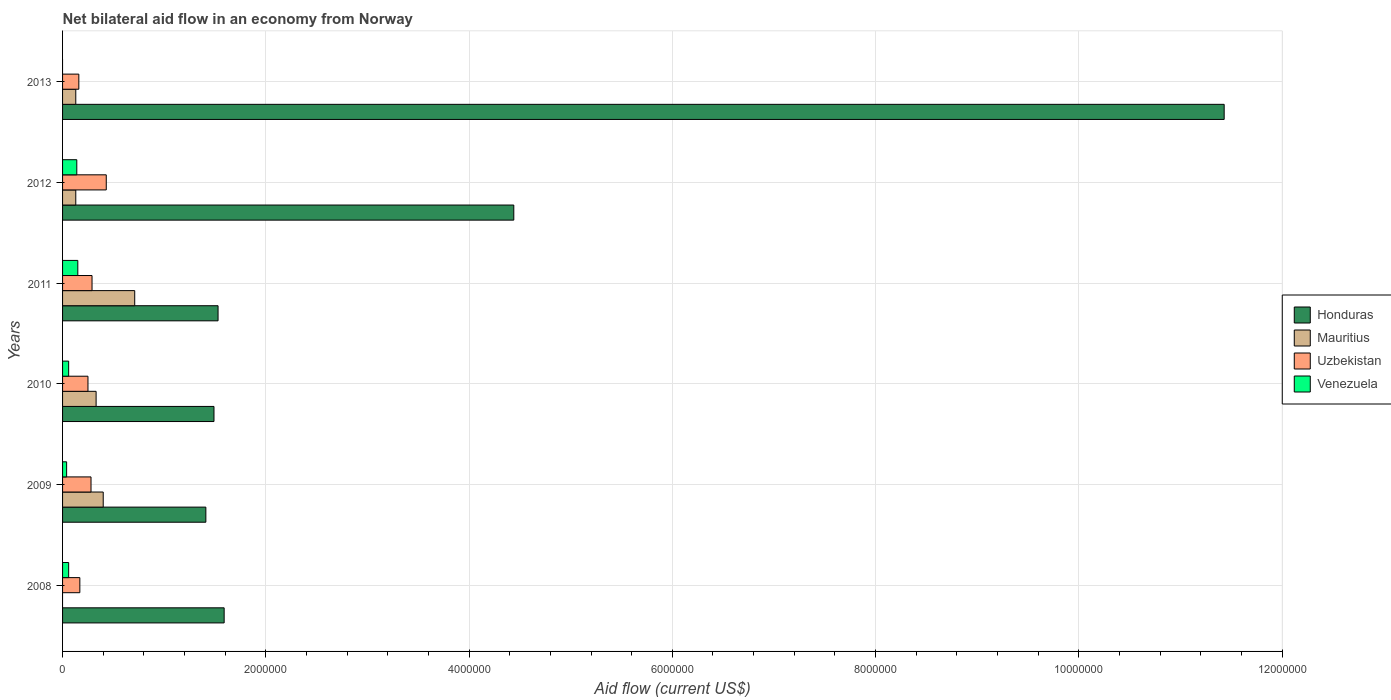Are the number of bars per tick equal to the number of legend labels?
Provide a short and direct response. No. In how many cases, is the number of bars for a given year not equal to the number of legend labels?
Provide a succinct answer. 2. What is the net bilateral aid flow in Venezuela in 2010?
Provide a short and direct response. 6.00e+04. Across all years, what is the maximum net bilateral aid flow in Mauritius?
Keep it short and to the point. 7.10e+05. In which year was the net bilateral aid flow in Venezuela maximum?
Your answer should be compact. 2011. What is the total net bilateral aid flow in Honduras in the graph?
Ensure brevity in your answer.  2.19e+07. What is the difference between the net bilateral aid flow in Honduras in 2008 and the net bilateral aid flow in Uzbekistan in 2013?
Provide a short and direct response. 1.43e+06. What is the average net bilateral aid flow in Honduras per year?
Offer a very short reply. 3.65e+06. In the year 2010, what is the difference between the net bilateral aid flow in Mauritius and net bilateral aid flow in Honduras?
Your answer should be compact. -1.16e+06. In how many years, is the net bilateral aid flow in Honduras greater than 8000000 US$?
Your answer should be compact. 1. What is the ratio of the net bilateral aid flow in Honduras in 2008 to that in 2011?
Ensure brevity in your answer.  1.04. Is the difference between the net bilateral aid flow in Mauritius in 2012 and 2013 greater than the difference between the net bilateral aid flow in Honduras in 2012 and 2013?
Offer a terse response. Yes. What is the difference between the highest and the second highest net bilateral aid flow in Venezuela?
Your answer should be compact. 10000. What is the difference between the highest and the lowest net bilateral aid flow in Mauritius?
Keep it short and to the point. 7.10e+05. Is the sum of the net bilateral aid flow in Venezuela in 2009 and 2010 greater than the maximum net bilateral aid flow in Mauritius across all years?
Keep it short and to the point. No. Is it the case that in every year, the sum of the net bilateral aid flow in Honduras and net bilateral aid flow in Uzbekistan is greater than the sum of net bilateral aid flow in Mauritius and net bilateral aid flow in Venezuela?
Provide a short and direct response. No. Are all the bars in the graph horizontal?
Provide a short and direct response. Yes. What is the difference between two consecutive major ticks on the X-axis?
Make the answer very short. 2.00e+06. Does the graph contain grids?
Make the answer very short. Yes. How many legend labels are there?
Offer a very short reply. 4. What is the title of the graph?
Keep it short and to the point. Net bilateral aid flow in an economy from Norway. What is the Aid flow (current US$) of Honduras in 2008?
Your answer should be compact. 1.59e+06. What is the Aid flow (current US$) of Honduras in 2009?
Your answer should be very brief. 1.41e+06. What is the Aid flow (current US$) of Mauritius in 2009?
Ensure brevity in your answer.  4.00e+05. What is the Aid flow (current US$) in Uzbekistan in 2009?
Provide a succinct answer. 2.80e+05. What is the Aid flow (current US$) in Honduras in 2010?
Ensure brevity in your answer.  1.49e+06. What is the Aid flow (current US$) in Honduras in 2011?
Offer a terse response. 1.53e+06. What is the Aid flow (current US$) of Mauritius in 2011?
Provide a succinct answer. 7.10e+05. What is the Aid flow (current US$) of Uzbekistan in 2011?
Your response must be concise. 2.90e+05. What is the Aid flow (current US$) in Venezuela in 2011?
Provide a succinct answer. 1.50e+05. What is the Aid flow (current US$) of Honduras in 2012?
Your answer should be compact. 4.44e+06. What is the Aid flow (current US$) of Venezuela in 2012?
Offer a terse response. 1.40e+05. What is the Aid flow (current US$) in Honduras in 2013?
Provide a succinct answer. 1.14e+07. What is the Aid flow (current US$) in Mauritius in 2013?
Give a very brief answer. 1.30e+05. What is the Aid flow (current US$) in Uzbekistan in 2013?
Keep it short and to the point. 1.60e+05. What is the Aid flow (current US$) of Venezuela in 2013?
Provide a succinct answer. 0. Across all years, what is the maximum Aid flow (current US$) in Honduras?
Provide a short and direct response. 1.14e+07. Across all years, what is the maximum Aid flow (current US$) of Mauritius?
Give a very brief answer. 7.10e+05. Across all years, what is the minimum Aid flow (current US$) in Honduras?
Your answer should be very brief. 1.41e+06. Across all years, what is the minimum Aid flow (current US$) in Mauritius?
Ensure brevity in your answer.  0. Across all years, what is the minimum Aid flow (current US$) in Uzbekistan?
Ensure brevity in your answer.  1.60e+05. Across all years, what is the minimum Aid flow (current US$) of Venezuela?
Make the answer very short. 0. What is the total Aid flow (current US$) in Honduras in the graph?
Keep it short and to the point. 2.19e+07. What is the total Aid flow (current US$) in Mauritius in the graph?
Offer a terse response. 1.70e+06. What is the total Aid flow (current US$) in Uzbekistan in the graph?
Your response must be concise. 1.58e+06. What is the difference between the Aid flow (current US$) of Honduras in 2008 and that in 2009?
Give a very brief answer. 1.80e+05. What is the difference between the Aid flow (current US$) of Uzbekistan in 2008 and that in 2009?
Your answer should be compact. -1.10e+05. What is the difference between the Aid flow (current US$) of Honduras in 2008 and that in 2011?
Ensure brevity in your answer.  6.00e+04. What is the difference between the Aid flow (current US$) in Uzbekistan in 2008 and that in 2011?
Offer a very short reply. -1.20e+05. What is the difference between the Aid flow (current US$) of Venezuela in 2008 and that in 2011?
Ensure brevity in your answer.  -9.00e+04. What is the difference between the Aid flow (current US$) in Honduras in 2008 and that in 2012?
Make the answer very short. -2.85e+06. What is the difference between the Aid flow (current US$) of Venezuela in 2008 and that in 2012?
Give a very brief answer. -8.00e+04. What is the difference between the Aid flow (current US$) of Honduras in 2008 and that in 2013?
Your answer should be very brief. -9.84e+06. What is the difference between the Aid flow (current US$) in Uzbekistan in 2008 and that in 2013?
Provide a succinct answer. 10000. What is the difference between the Aid flow (current US$) in Honduras in 2009 and that in 2010?
Your answer should be very brief. -8.00e+04. What is the difference between the Aid flow (current US$) in Mauritius in 2009 and that in 2010?
Your response must be concise. 7.00e+04. What is the difference between the Aid flow (current US$) in Uzbekistan in 2009 and that in 2010?
Provide a short and direct response. 3.00e+04. What is the difference between the Aid flow (current US$) of Venezuela in 2009 and that in 2010?
Give a very brief answer. -2.00e+04. What is the difference between the Aid flow (current US$) of Mauritius in 2009 and that in 2011?
Offer a terse response. -3.10e+05. What is the difference between the Aid flow (current US$) in Honduras in 2009 and that in 2012?
Offer a terse response. -3.03e+06. What is the difference between the Aid flow (current US$) of Venezuela in 2009 and that in 2012?
Provide a succinct answer. -1.00e+05. What is the difference between the Aid flow (current US$) in Honduras in 2009 and that in 2013?
Your answer should be very brief. -1.00e+07. What is the difference between the Aid flow (current US$) of Mauritius in 2009 and that in 2013?
Provide a short and direct response. 2.70e+05. What is the difference between the Aid flow (current US$) in Uzbekistan in 2009 and that in 2013?
Offer a terse response. 1.20e+05. What is the difference between the Aid flow (current US$) of Mauritius in 2010 and that in 2011?
Give a very brief answer. -3.80e+05. What is the difference between the Aid flow (current US$) of Uzbekistan in 2010 and that in 2011?
Your answer should be compact. -4.00e+04. What is the difference between the Aid flow (current US$) of Venezuela in 2010 and that in 2011?
Offer a very short reply. -9.00e+04. What is the difference between the Aid flow (current US$) of Honduras in 2010 and that in 2012?
Offer a terse response. -2.95e+06. What is the difference between the Aid flow (current US$) of Mauritius in 2010 and that in 2012?
Ensure brevity in your answer.  2.00e+05. What is the difference between the Aid flow (current US$) in Uzbekistan in 2010 and that in 2012?
Offer a terse response. -1.80e+05. What is the difference between the Aid flow (current US$) in Venezuela in 2010 and that in 2012?
Your answer should be compact. -8.00e+04. What is the difference between the Aid flow (current US$) in Honduras in 2010 and that in 2013?
Give a very brief answer. -9.94e+06. What is the difference between the Aid flow (current US$) in Mauritius in 2010 and that in 2013?
Offer a very short reply. 2.00e+05. What is the difference between the Aid flow (current US$) in Uzbekistan in 2010 and that in 2013?
Give a very brief answer. 9.00e+04. What is the difference between the Aid flow (current US$) of Honduras in 2011 and that in 2012?
Offer a very short reply. -2.91e+06. What is the difference between the Aid flow (current US$) of Mauritius in 2011 and that in 2012?
Keep it short and to the point. 5.80e+05. What is the difference between the Aid flow (current US$) of Uzbekistan in 2011 and that in 2012?
Your response must be concise. -1.40e+05. What is the difference between the Aid flow (current US$) in Venezuela in 2011 and that in 2012?
Provide a succinct answer. 10000. What is the difference between the Aid flow (current US$) of Honduras in 2011 and that in 2013?
Offer a very short reply. -9.90e+06. What is the difference between the Aid flow (current US$) in Mauritius in 2011 and that in 2013?
Offer a terse response. 5.80e+05. What is the difference between the Aid flow (current US$) of Uzbekistan in 2011 and that in 2013?
Your response must be concise. 1.30e+05. What is the difference between the Aid flow (current US$) in Honduras in 2012 and that in 2013?
Your response must be concise. -6.99e+06. What is the difference between the Aid flow (current US$) in Mauritius in 2012 and that in 2013?
Your answer should be very brief. 0. What is the difference between the Aid flow (current US$) of Uzbekistan in 2012 and that in 2013?
Your response must be concise. 2.70e+05. What is the difference between the Aid flow (current US$) in Honduras in 2008 and the Aid flow (current US$) in Mauritius in 2009?
Offer a very short reply. 1.19e+06. What is the difference between the Aid flow (current US$) of Honduras in 2008 and the Aid flow (current US$) of Uzbekistan in 2009?
Ensure brevity in your answer.  1.31e+06. What is the difference between the Aid flow (current US$) in Honduras in 2008 and the Aid flow (current US$) in Venezuela in 2009?
Your answer should be compact. 1.55e+06. What is the difference between the Aid flow (current US$) in Uzbekistan in 2008 and the Aid flow (current US$) in Venezuela in 2009?
Keep it short and to the point. 1.30e+05. What is the difference between the Aid flow (current US$) of Honduras in 2008 and the Aid flow (current US$) of Mauritius in 2010?
Give a very brief answer. 1.26e+06. What is the difference between the Aid flow (current US$) in Honduras in 2008 and the Aid flow (current US$) in Uzbekistan in 2010?
Your answer should be very brief. 1.34e+06. What is the difference between the Aid flow (current US$) in Honduras in 2008 and the Aid flow (current US$) in Venezuela in 2010?
Your answer should be compact. 1.53e+06. What is the difference between the Aid flow (current US$) in Uzbekistan in 2008 and the Aid flow (current US$) in Venezuela in 2010?
Provide a succinct answer. 1.10e+05. What is the difference between the Aid flow (current US$) of Honduras in 2008 and the Aid flow (current US$) of Mauritius in 2011?
Offer a very short reply. 8.80e+05. What is the difference between the Aid flow (current US$) in Honduras in 2008 and the Aid flow (current US$) in Uzbekistan in 2011?
Your response must be concise. 1.30e+06. What is the difference between the Aid flow (current US$) of Honduras in 2008 and the Aid flow (current US$) of Venezuela in 2011?
Keep it short and to the point. 1.44e+06. What is the difference between the Aid flow (current US$) in Honduras in 2008 and the Aid flow (current US$) in Mauritius in 2012?
Provide a succinct answer. 1.46e+06. What is the difference between the Aid flow (current US$) in Honduras in 2008 and the Aid flow (current US$) in Uzbekistan in 2012?
Offer a very short reply. 1.16e+06. What is the difference between the Aid flow (current US$) of Honduras in 2008 and the Aid flow (current US$) of Venezuela in 2012?
Your response must be concise. 1.45e+06. What is the difference between the Aid flow (current US$) of Uzbekistan in 2008 and the Aid flow (current US$) of Venezuela in 2012?
Ensure brevity in your answer.  3.00e+04. What is the difference between the Aid flow (current US$) in Honduras in 2008 and the Aid flow (current US$) in Mauritius in 2013?
Make the answer very short. 1.46e+06. What is the difference between the Aid flow (current US$) of Honduras in 2008 and the Aid flow (current US$) of Uzbekistan in 2013?
Offer a very short reply. 1.43e+06. What is the difference between the Aid flow (current US$) in Honduras in 2009 and the Aid flow (current US$) in Mauritius in 2010?
Provide a short and direct response. 1.08e+06. What is the difference between the Aid flow (current US$) of Honduras in 2009 and the Aid flow (current US$) of Uzbekistan in 2010?
Your answer should be compact. 1.16e+06. What is the difference between the Aid flow (current US$) of Honduras in 2009 and the Aid flow (current US$) of Venezuela in 2010?
Your response must be concise. 1.35e+06. What is the difference between the Aid flow (current US$) of Honduras in 2009 and the Aid flow (current US$) of Uzbekistan in 2011?
Offer a terse response. 1.12e+06. What is the difference between the Aid flow (current US$) in Honduras in 2009 and the Aid flow (current US$) in Venezuela in 2011?
Keep it short and to the point. 1.26e+06. What is the difference between the Aid flow (current US$) of Mauritius in 2009 and the Aid flow (current US$) of Venezuela in 2011?
Provide a short and direct response. 2.50e+05. What is the difference between the Aid flow (current US$) of Uzbekistan in 2009 and the Aid flow (current US$) of Venezuela in 2011?
Provide a short and direct response. 1.30e+05. What is the difference between the Aid flow (current US$) of Honduras in 2009 and the Aid flow (current US$) of Mauritius in 2012?
Ensure brevity in your answer.  1.28e+06. What is the difference between the Aid flow (current US$) of Honduras in 2009 and the Aid flow (current US$) of Uzbekistan in 2012?
Keep it short and to the point. 9.80e+05. What is the difference between the Aid flow (current US$) in Honduras in 2009 and the Aid flow (current US$) in Venezuela in 2012?
Provide a short and direct response. 1.27e+06. What is the difference between the Aid flow (current US$) of Mauritius in 2009 and the Aid flow (current US$) of Uzbekistan in 2012?
Make the answer very short. -3.00e+04. What is the difference between the Aid flow (current US$) of Uzbekistan in 2009 and the Aid flow (current US$) of Venezuela in 2012?
Offer a terse response. 1.40e+05. What is the difference between the Aid flow (current US$) of Honduras in 2009 and the Aid flow (current US$) of Mauritius in 2013?
Your answer should be compact. 1.28e+06. What is the difference between the Aid flow (current US$) in Honduras in 2009 and the Aid flow (current US$) in Uzbekistan in 2013?
Make the answer very short. 1.25e+06. What is the difference between the Aid flow (current US$) in Mauritius in 2009 and the Aid flow (current US$) in Uzbekistan in 2013?
Provide a succinct answer. 2.40e+05. What is the difference between the Aid flow (current US$) in Honduras in 2010 and the Aid flow (current US$) in Mauritius in 2011?
Your response must be concise. 7.80e+05. What is the difference between the Aid flow (current US$) in Honduras in 2010 and the Aid flow (current US$) in Uzbekistan in 2011?
Your answer should be compact. 1.20e+06. What is the difference between the Aid flow (current US$) of Honduras in 2010 and the Aid flow (current US$) of Venezuela in 2011?
Keep it short and to the point. 1.34e+06. What is the difference between the Aid flow (current US$) of Mauritius in 2010 and the Aid flow (current US$) of Uzbekistan in 2011?
Your response must be concise. 4.00e+04. What is the difference between the Aid flow (current US$) of Mauritius in 2010 and the Aid flow (current US$) of Venezuela in 2011?
Make the answer very short. 1.80e+05. What is the difference between the Aid flow (current US$) in Uzbekistan in 2010 and the Aid flow (current US$) in Venezuela in 2011?
Provide a succinct answer. 1.00e+05. What is the difference between the Aid flow (current US$) in Honduras in 2010 and the Aid flow (current US$) in Mauritius in 2012?
Ensure brevity in your answer.  1.36e+06. What is the difference between the Aid flow (current US$) of Honduras in 2010 and the Aid flow (current US$) of Uzbekistan in 2012?
Give a very brief answer. 1.06e+06. What is the difference between the Aid flow (current US$) of Honduras in 2010 and the Aid flow (current US$) of Venezuela in 2012?
Provide a short and direct response. 1.35e+06. What is the difference between the Aid flow (current US$) of Mauritius in 2010 and the Aid flow (current US$) of Venezuela in 2012?
Keep it short and to the point. 1.90e+05. What is the difference between the Aid flow (current US$) of Uzbekistan in 2010 and the Aid flow (current US$) of Venezuela in 2012?
Your answer should be very brief. 1.10e+05. What is the difference between the Aid flow (current US$) in Honduras in 2010 and the Aid flow (current US$) in Mauritius in 2013?
Offer a very short reply. 1.36e+06. What is the difference between the Aid flow (current US$) of Honduras in 2010 and the Aid flow (current US$) of Uzbekistan in 2013?
Your response must be concise. 1.33e+06. What is the difference between the Aid flow (current US$) of Mauritius in 2010 and the Aid flow (current US$) of Uzbekistan in 2013?
Provide a short and direct response. 1.70e+05. What is the difference between the Aid flow (current US$) in Honduras in 2011 and the Aid flow (current US$) in Mauritius in 2012?
Offer a very short reply. 1.40e+06. What is the difference between the Aid flow (current US$) of Honduras in 2011 and the Aid flow (current US$) of Uzbekistan in 2012?
Offer a terse response. 1.10e+06. What is the difference between the Aid flow (current US$) of Honduras in 2011 and the Aid flow (current US$) of Venezuela in 2012?
Offer a terse response. 1.39e+06. What is the difference between the Aid flow (current US$) in Mauritius in 2011 and the Aid flow (current US$) in Uzbekistan in 2012?
Your answer should be very brief. 2.80e+05. What is the difference between the Aid flow (current US$) of Mauritius in 2011 and the Aid flow (current US$) of Venezuela in 2012?
Offer a very short reply. 5.70e+05. What is the difference between the Aid flow (current US$) in Honduras in 2011 and the Aid flow (current US$) in Mauritius in 2013?
Keep it short and to the point. 1.40e+06. What is the difference between the Aid flow (current US$) in Honduras in 2011 and the Aid flow (current US$) in Uzbekistan in 2013?
Make the answer very short. 1.37e+06. What is the difference between the Aid flow (current US$) in Mauritius in 2011 and the Aid flow (current US$) in Uzbekistan in 2013?
Offer a very short reply. 5.50e+05. What is the difference between the Aid flow (current US$) in Honduras in 2012 and the Aid flow (current US$) in Mauritius in 2013?
Provide a succinct answer. 4.31e+06. What is the difference between the Aid flow (current US$) in Honduras in 2012 and the Aid flow (current US$) in Uzbekistan in 2013?
Ensure brevity in your answer.  4.28e+06. What is the average Aid flow (current US$) of Honduras per year?
Offer a terse response. 3.65e+06. What is the average Aid flow (current US$) of Mauritius per year?
Offer a very short reply. 2.83e+05. What is the average Aid flow (current US$) in Uzbekistan per year?
Make the answer very short. 2.63e+05. What is the average Aid flow (current US$) in Venezuela per year?
Provide a short and direct response. 7.50e+04. In the year 2008, what is the difference between the Aid flow (current US$) of Honduras and Aid flow (current US$) of Uzbekistan?
Your response must be concise. 1.42e+06. In the year 2008, what is the difference between the Aid flow (current US$) of Honduras and Aid flow (current US$) of Venezuela?
Your answer should be compact. 1.53e+06. In the year 2009, what is the difference between the Aid flow (current US$) in Honduras and Aid flow (current US$) in Mauritius?
Your answer should be very brief. 1.01e+06. In the year 2009, what is the difference between the Aid flow (current US$) of Honduras and Aid flow (current US$) of Uzbekistan?
Give a very brief answer. 1.13e+06. In the year 2009, what is the difference between the Aid flow (current US$) in Honduras and Aid flow (current US$) in Venezuela?
Keep it short and to the point. 1.37e+06. In the year 2010, what is the difference between the Aid flow (current US$) of Honduras and Aid flow (current US$) of Mauritius?
Ensure brevity in your answer.  1.16e+06. In the year 2010, what is the difference between the Aid flow (current US$) in Honduras and Aid flow (current US$) in Uzbekistan?
Ensure brevity in your answer.  1.24e+06. In the year 2010, what is the difference between the Aid flow (current US$) of Honduras and Aid flow (current US$) of Venezuela?
Offer a very short reply. 1.43e+06. In the year 2010, what is the difference between the Aid flow (current US$) of Mauritius and Aid flow (current US$) of Venezuela?
Provide a succinct answer. 2.70e+05. In the year 2010, what is the difference between the Aid flow (current US$) of Uzbekistan and Aid flow (current US$) of Venezuela?
Your answer should be compact. 1.90e+05. In the year 2011, what is the difference between the Aid flow (current US$) of Honduras and Aid flow (current US$) of Mauritius?
Make the answer very short. 8.20e+05. In the year 2011, what is the difference between the Aid flow (current US$) of Honduras and Aid flow (current US$) of Uzbekistan?
Provide a succinct answer. 1.24e+06. In the year 2011, what is the difference between the Aid flow (current US$) in Honduras and Aid flow (current US$) in Venezuela?
Keep it short and to the point. 1.38e+06. In the year 2011, what is the difference between the Aid flow (current US$) of Mauritius and Aid flow (current US$) of Venezuela?
Your answer should be very brief. 5.60e+05. In the year 2011, what is the difference between the Aid flow (current US$) in Uzbekistan and Aid flow (current US$) in Venezuela?
Offer a terse response. 1.40e+05. In the year 2012, what is the difference between the Aid flow (current US$) of Honduras and Aid flow (current US$) of Mauritius?
Provide a short and direct response. 4.31e+06. In the year 2012, what is the difference between the Aid flow (current US$) of Honduras and Aid flow (current US$) of Uzbekistan?
Offer a terse response. 4.01e+06. In the year 2012, what is the difference between the Aid flow (current US$) in Honduras and Aid flow (current US$) in Venezuela?
Provide a short and direct response. 4.30e+06. In the year 2012, what is the difference between the Aid flow (current US$) in Mauritius and Aid flow (current US$) in Venezuela?
Give a very brief answer. -10000. In the year 2013, what is the difference between the Aid flow (current US$) of Honduras and Aid flow (current US$) of Mauritius?
Offer a terse response. 1.13e+07. In the year 2013, what is the difference between the Aid flow (current US$) of Honduras and Aid flow (current US$) of Uzbekistan?
Provide a succinct answer. 1.13e+07. In the year 2013, what is the difference between the Aid flow (current US$) of Mauritius and Aid flow (current US$) of Uzbekistan?
Ensure brevity in your answer.  -3.00e+04. What is the ratio of the Aid flow (current US$) of Honduras in 2008 to that in 2009?
Your answer should be compact. 1.13. What is the ratio of the Aid flow (current US$) of Uzbekistan in 2008 to that in 2009?
Give a very brief answer. 0.61. What is the ratio of the Aid flow (current US$) of Honduras in 2008 to that in 2010?
Offer a terse response. 1.07. What is the ratio of the Aid flow (current US$) of Uzbekistan in 2008 to that in 2010?
Give a very brief answer. 0.68. What is the ratio of the Aid flow (current US$) of Venezuela in 2008 to that in 2010?
Ensure brevity in your answer.  1. What is the ratio of the Aid flow (current US$) of Honduras in 2008 to that in 2011?
Provide a short and direct response. 1.04. What is the ratio of the Aid flow (current US$) in Uzbekistan in 2008 to that in 2011?
Give a very brief answer. 0.59. What is the ratio of the Aid flow (current US$) of Venezuela in 2008 to that in 2011?
Offer a very short reply. 0.4. What is the ratio of the Aid flow (current US$) of Honduras in 2008 to that in 2012?
Give a very brief answer. 0.36. What is the ratio of the Aid flow (current US$) in Uzbekistan in 2008 to that in 2012?
Ensure brevity in your answer.  0.4. What is the ratio of the Aid flow (current US$) of Venezuela in 2008 to that in 2012?
Keep it short and to the point. 0.43. What is the ratio of the Aid flow (current US$) in Honduras in 2008 to that in 2013?
Offer a terse response. 0.14. What is the ratio of the Aid flow (current US$) of Uzbekistan in 2008 to that in 2013?
Ensure brevity in your answer.  1.06. What is the ratio of the Aid flow (current US$) in Honduras in 2009 to that in 2010?
Ensure brevity in your answer.  0.95. What is the ratio of the Aid flow (current US$) in Mauritius in 2009 to that in 2010?
Ensure brevity in your answer.  1.21. What is the ratio of the Aid flow (current US$) in Uzbekistan in 2009 to that in 2010?
Your answer should be compact. 1.12. What is the ratio of the Aid flow (current US$) in Honduras in 2009 to that in 2011?
Ensure brevity in your answer.  0.92. What is the ratio of the Aid flow (current US$) of Mauritius in 2009 to that in 2011?
Your answer should be very brief. 0.56. What is the ratio of the Aid flow (current US$) in Uzbekistan in 2009 to that in 2011?
Your answer should be very brief. 0.97. What is the ratio of the Aid flow (current US$) in Venezuela in 2009 to that in 2011?
Offer a very short reply. 0.27. What is the ratio of the Aid flow (current US$) in Honduras in 2009 to that in 2012?
Offer a very short reply. 0.32. What is the ratio of the Aid flow (current US$) in Mauritius in 2009 to that in 2012?
Provide a succinct answer. 3.08. What is the ratio of the Aid flow (current US$) in Uzbekistan in 2009 to that in 2012?
Give a very brief answer. 0.65. What is the ratio of the Aid flow (current US$) in Venezuela in 2009 to that in 2012?
Provide a short and direct response. 0.29. What is the ratio of the Aid flow (current US$) in Honduras in 2009 to that in 2013?
Your response must be concise. 0.12. What is the ratio of the Aid flow (current US$) in Mauritius in 2009 to that in 2013?
Make the answer very short. 3.08. What is the ratio of the Aid flow (current US$) of Uzbekistan in 2009 to that in 2013?
Provide a succinct answer. 1.75. What is the ratio of the Aid flow (current US$) in Honduras in 2010 to that in 2011?
Provide a short and direct response. 0.97. What is the ratio of the Aid flow (current US$) of Mauritius in 2010 to that in 2011?
Your answer should be very brief. 0.46. What is the ratio of the Aid flow (current US$) in Uzbekistan in 2010 to that in 2011?
Provide a short and direct response. 0.86. What is the ratio of the Aid flow (current US$) of Venezuela in 2010 to that in 2011?
Your answer should be very brief. 0.4. What is the ratio of the Aid flow (current US$) of Honduras in 2010 to that in 2012?
Provide a succinct answer. 0.34. What is the ratio of the Aid flow (current US$) in Mauritius in 2010 to that in 2012?
Give a very brief answer. 2.54. What is the ratio of the Aid flow (current US$) in Uzbekistan in 2010 to that in 2012?
Offer a very short reply. 0.58. What is the ratio of the Aid flow (current US$) of Venezuela in 2010 to that in 2012?
Offer a very short reply. 0.43. What is the ratio of the Aid flow (current US$) of Honduras in 2010 to that in 2013?
Offer a very short reply. 0.13. What is the ratio of the Aid flow (current US$) in Mauritius in 2010 to that in 2013?
Provide a succinct answer. 2.54. What is the ratio of the Aid flow (current US$) in Uzbekistan in 2010 to that in 2013?
Ensure brevity in your answer.  1.56. What is the ratio of the Aid flow (current US$) in Honduras in 2011 to that in 2012?
Your answer should be very brief. 0.34. What is the ratio of the Aid flow (current US$) of Mauritius in 2011 to that in 2012?
Make the answer very short. 5.46. What is the ratio of the Aid flow (current US$) in Uzbekistan in 2011 to that in 2012?
Your response must be concise. 0.67. What is the ratio of the Aid flow (current US$) in Venezuela in 2011 to that in 2012?
Ensure brevity in your answer.  1.07. What is the ratio of the Aid flow (current US$) in Honduras in 2011 to that in 2013?
Make the answer very short. 0.13. What is the ratio of the Aid flow (current US$) of Mauritius in 2011 to that in 2013?
Provide a succinct answer. 5.46. What is the ratio of the Aid flow (current US$) of Uzbekistan in 2011 to that in 2013?
Keep it short and to the point. 1.81. What is the ratio of the Aid flow (current US$) in Honduras in 2012 to that in 2013?
Ensure brevity in your answer.  0.39. What is the ratio of the Aid flow (current US$) of Mauritius in 2012 to that in 2013?
Your answer should be compact. 1. What is the ratio of the Aid flow (current US$) of Uzbekistan in 2012 to that in 2013?
Offer a terse response. 2.69. What is the difference between the highest and the second highest Aid flow (current US$) in Honduras?
Make the answer very short. 6.99e+06. What is the difference between the highest and the second highest Aid flow (current US$) in Uzbekistan?
Your answer should be very brief. 1.40e+05. What is the difference between the highest and the lowest Aid flow (current US$) in Honduras?
Your answer should be compact. 1.00e+07. What is the difference between the highest and the lowest Aid flow (current US$) in Mauritius?
Offer a very short reply. 7.10e+05. What is the difference between the highest and the lowest Aid flow (current US$) of Uzbekistan?
Provide a short and direct response. 2.70e+05. 